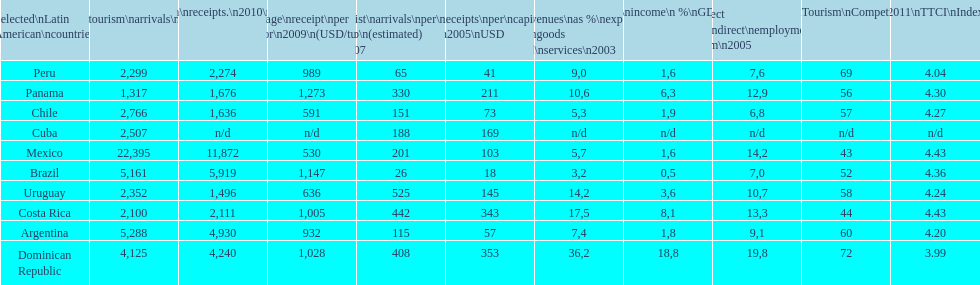What country makes the most tourist income? Dominican Republic. 